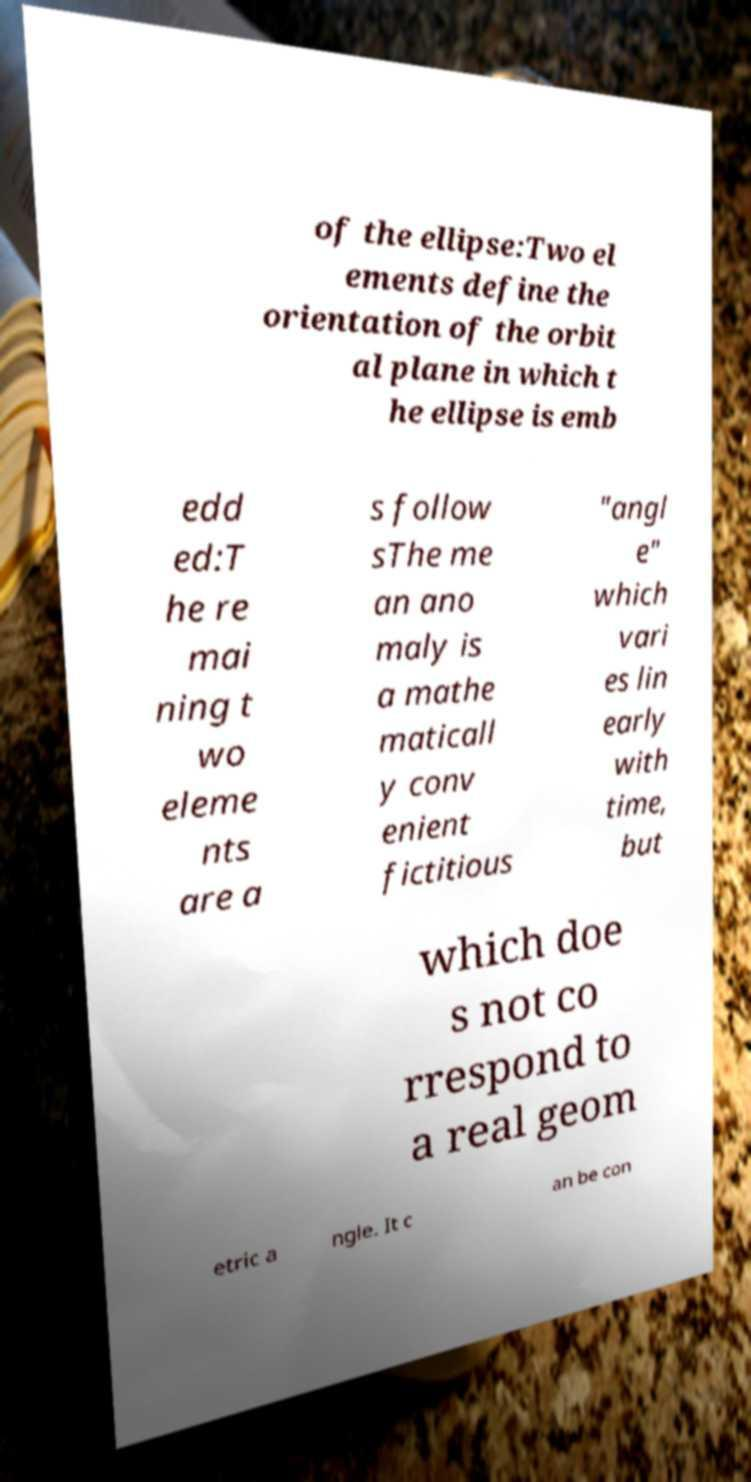Can you accurately transcribe the text from the provided image for me? of the ellipse:Two el ements define the orientation of the orbit al plane in which t he ellipse is emb edd ed:T he re mai ning t wo eleme nts are a s follow sThe me an ano maly is a mathe maticall y conv enient fictitious "angl e" which vari es lin early with time, but which doe s not co rrespond to a real geom etric a ngle. It c an be con 